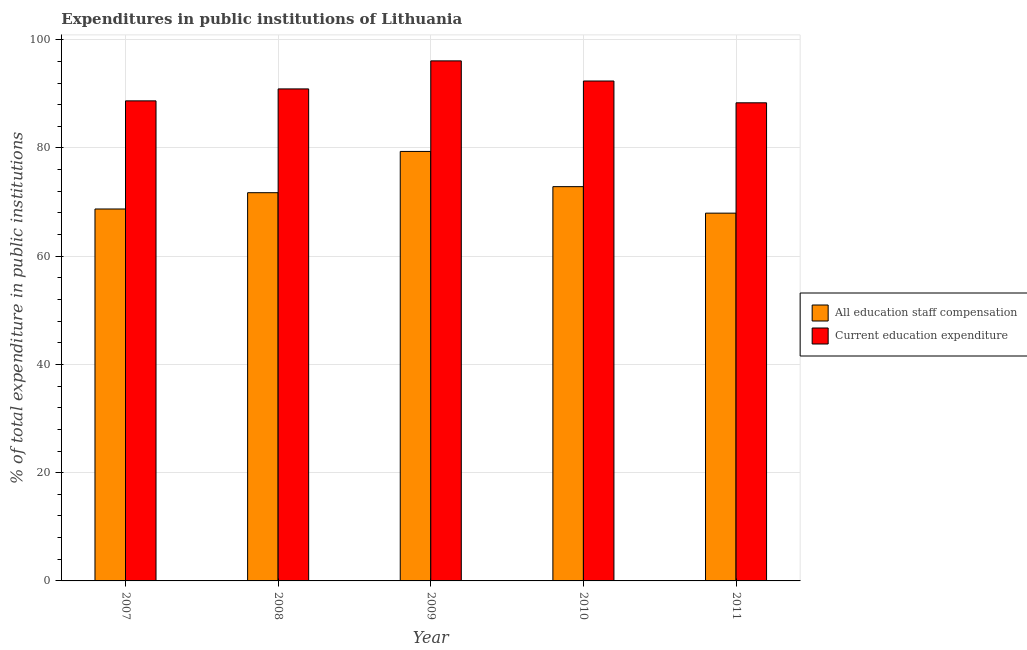How many groups of bars are there?
Make the answer very short. 5. Are the number of bars per tick equal to the number of legend labels?
Your answer should be compact. Yes. Are the number of bars on each tick of the X-axis equal?
Your answer should be compact. Yes. How many bars are there on the 3rd tick from the left?
Make the answer very short. 2. What is the expenditure in staff compensation in 2009?
Your answer should be very brief. 79.36. Across all years, what is the maximum expenditure in education?
Give a very brief answer. 96.09. Across all years, what is the minimum expenditure in education?
Your answer should be compact. 88.34. What is the total expenditure in staff compensation in the graph?
Offer a terse response. 360.62. What is the difference between the expenditure in education in 2008 and that in 2010?
Ensure brevity in your answer.  -1.46. What is the difference between the expenditure in staff compensation in 2008 and the expenditure in education in 2007?
Offer a terse response. 3.01. What is the average expenditure in education per year?
Keep it short and to the point. 91.28. In how many years, is the expenditure in education greater than 64 %?
Provide a succinct answer. 5. What is the ratio of the expenditure in staff compensation in 2007 to that in 2011?
Your answer should be compact. 1.01. Is the expenditure in staff compensation in 2010 less than that in 2011?
Your response must be concise. No. What is the difference between the highest and the second highest expenditure in education?
Your answer should be very brief. 3.72. What is the difference between the highest and the lowest expenditure in staff compensation?
Your answer should be very brief. 11.4. Is the sum of the expenditure in staff compensation in 2007 and 2009 greater than the maximum expenditure in education across all years?
Offer a terse response. Yes. What does the 2nd bar from the left in 2011 represents?
Your answer should be very brief. Current education expenditure. What does the 1st bar from the right in 2008 represents?
Provide a succinct answer. Current education expenditure. How many bars are there?
Keep it short and to the point. 10. Are all the bars in the graph horizontal?
Offer a very short reply. No. How many years are there in the graph?
Make the answer very short. 5. What is the difference between two consecutive major ticks on the Y-axis?
Provide a succinct answer. 20. Are the values on the major ticks of Y-axis written in scientific E-notation?
Your answer should be very brief. No. Does the graph contain any zero values?
Your answer should be compact. No. Does the graph contain grids?
Ensure brevity in your answer.  Yes. How many legend labels are there?
Keep it short and to the point. 2. How are the legend labels stacked?
Your answer should be very brief. Vertical. What is the title of the graph?
Ensure brevity in your answer.  Expenditures in public institutions of Lithuania. What is the label or title of the X-axis?
Provide a short and direct response. Year. What is the label or title of the Y-axis?
Your response must be concise. % of total expenditure in public institutions. What is the % of total expenditure in public institutions of All education staff compensation in 2007?
Offer a very short reply. 68.72. What is the % of total expenditure in public institutions in Current education expenditure in 2007?
Offer a very short reply. 88.7. What is the % of total expenditure in public institutions of All education staff compensation in 2008?
Offer a terse response. 71.73. What is the % of total expenditure in public institutions of Current education expenditure in 2008?
Give a very brief answer. 90.91. What is the % of total expenditure in public institutions of All education staff compensation in 2009?
Your response must be concise. 79.36. What is the % of total expenditure in public institutions of Current education expenditure in 2009?
Provide a short and direct response. 96.09. What is the % of total expenditure in public institutions of All education staff compensation in 2010?
Provide a succinct answer. 72.85. What is the % of total expenditure in public institutions of Current education expenditure in 2010?
Make the answer very short. 92.37. What is the % of total expenditure in public institutions of All education staff compensation in 2011?
Ensure brevity in your answer.  67.96. What is the % of total expenditure in public institutions of Current education expenditure in 2011?
Keep it short and to the point. 88.34. Across all years, what is the maximum % of total expenditure in public institutions in All education staff compensation?
Offer a terse response. 79.36. Across all years, what is the maximum % of total expenditure in public institutions of Current education expenditure?
Keep it short and to the point. 96.09. Across all years, what is the minimum % of total expenditure in public institutions in All education staff compensation?
Provide a succinct answer. 67.96. Across all years, what is the minimum % of total expenditure in public institutions of Current education expenditure?
Offer a terse response. 88.34. What is the total % of total expenditure in public institutions in All education staff compensation in the graph?
Provide a short and direct response. 360.62. What is the total % of total expenditure in public institutions in Current education expenditure in the graph?
Ensure brevity in your answer.  456.42. What is the difference between the % of total expenditure in public institutions in All education staff compensation in 2007 and that in 2008?
Ensure brevity in your answer.  -3.01. What is the difference between the % of total expenditure in public institutions in Current education expenditure in 2007 and that in 2008?
Your answer should be very brief. -2.21. What is the difference between the % of total expenditure in public institutions in All education staff compensation in 2007 and that in 2009?
Provide a short and direct response. -10.63. What is the difference between the % of total expenditure in public institutions in Current education expenditure in 2007 and that in 2009?
Keep it short and to the point. -7.39. What is the difference between the % of total expenditure in public institutions in All education staff compensation in 2007 and that in 2010?
Give a very brief answer. -4.13. What is the difference between the % of total expenditure in public institutions of Current education expenditure in 2007 and that in 2010?
Your answer should be very brief. -3.67. What is the difference between the % of total expenditure in public institutions in All education staff compensation in 2007 and that in 2011?
Provide a short and direct response. 0.77. What is the difference between the % of total expenditure in public institutions of Current education expenditure in 2007 and that in 2011?
Offer a very short reply. 0.36. What is the difference between the % of total expenditure in public institutions in All education staff compensation in 2008 and that in 2009?
Your answer should be compact. -7.62. What is the difference between the % of total expenditure in public institutions in Current education expenditure in 2008 and that in 2009?
Your answer should be very brief. -5.18. What is the difference between the % of total expenditure in public institutions in All education staff compensation in 2008 and that in 2010?
Ensure brevity in your answer.  -1.12. What is the difference between the % of total expenditure in public institutions in Current education expenditure in 2008 and that in 2010?
Your response must be concise. -1.46. What is the difference between the % of total expenditure in public institutions of All education staff compensation in 2008 and that in 2011?
Your answer should be very brief. 3.78. What is the difference between the % of total expenditure in public institutions in Current education expenditure in 2008 and that in 2011?
Ensure brevity in your answer.  2.57. What is the difference between the % of total expenditure in public institutions in All education staff compensation in 2009 and that in 2010?
Offer a very short reply. 6.51. What is the difference between the % of total expenditure in public institutions in Current education expenditure in 2009 and that in 2010?
Make the answer very short. 3.72. What is the difference between the % of total expenditure in public institutions of All education staff compensation in 2009 and that in 2011?
Give a very brief answer. 11.4. What is the difference between the % of total expenditure in public institutions of Current education expenditure in 2009 and that in 2011?
Provide a short and direct response. 7.75. What is the difference between the % of total expenditure in public institutions of All education staff compensation in 2010 and that in 2011?
Your response must be concise. 4.89. What is the difference between the % of total expenditure in public institutions in Current education expenditure in 2010 and that in 2011?
Keep it short and to the point. 4.03. What is the difference between the % of total expenditure in public institutions in All education staff compensation in 2007 and the % of total expenditure in public institutions in Current education expenditure in 2008?
Offer a very short reply. -22.19. What is the difference between the % of total expenditure in public institutions of All education staff compensation in 2007 and the % of total expenditure in public institutions of Current education expenditure in 2009?
Provide a short and direct response. -27.37. What is the difference between the % of total expenditure in public institutions of All education staff compensation in 2007 and the % of total expenditure in public institutions of Current education expenditure in 2010?
Provide a short and direct response. -23.65. What is the difference between the % of total expenditure in public institutions in All education staff compensation in 2007 and the % of total expenditure in public institutions in Current education expenditure in 2011?
Ensure brevity in your answer.  -19.62. What is the difference between the % of total expenditure in public institutions of All education staff compensation in 2008 and the % of total expenditure in public institutions of Current education expenditure in 2009?
Ensure brevity in your answer.  -24.36. What is the difference between the % of total expenditure in public institutions of All education staff compensation in 2008 and the % of total expenditure in public institutions of Current education expenditure in 2010?
Give a very brief answer. -20.64. What is the difference between the % of total expenditure in public institutions in All education staff compensation in 2008 and the % of total expenditure in public institutions in Current education expenditure in 2011?
Give a very brief answer. -16.61. What is the difference between the % of total expenditure in public institutions of All education staff compensation in 2009 and the % of total expenditure in public institutions of Current education expenditure in 2010?
Offer a terse response. -13.01. What is the difference between the % of total expenditure in public institutions in All education staff compensation in 2009 and the % of total expenditure in public institutions in Current education expenditure in 2011?
Keep it short and to the point. -8.99. What is the difference between the % of total expenditure in public institutions in All education staff compensation in 2010 and the % of total expenditure in public institutions in Current education expenditure in 2011?
Ensure brevity in your answer.  -15.49. What is the average % of total expenditure in public institutions of All education staff compensation per year?
Ensure brevity in your answer.  72.12. What is the average % of total expenditure in public institutions of Current education expenditure per year?
Your answer should be compact. 91.28. In the year 2007, what is the difference between the % of total expenditure in public institutions of All education staff compensation and % of total expenditure in public institutions of Current education expenditure?
Provide a succinct answer. -19.98. In the year 2008, what is the difference between the % of total expenditure in public institutions in All education staff compensation and % of total expenditure in public institutions in Current education expenditure?
Your answer should be compact. -19.18. In the year 2009, what is the difference between the % of total expenditure in public institutions of All education staff compensation and % of total expenditure in public institutions of Current education expenditure?
Ensure brevity in your answer.  -16.73. In the year 2010, what is the difference between the % of total expenditure in public institutions in All education staff compensation and % of total expenditure in public institutions in Current education expenditure?
Your answer should be very brief. -19.52. In the year 2011, what is the difference between the % of total expenditure in public institutions of All education staff compensation and % of total expenditure in public institutions of Current education expenditure?
Your response must be concise. -20.39. What is the ratio of the % of total expenditure in public institutions of All education staff compensation in 2007 to that in 2008?
Provide a short and direct response. 0.96. What is the ratio of the % of total expenditure in public institutions in Current education expenditure in 2007 to that in 2008?
Offer a terse response. 0.98. What is the ratio of the % of total expenditure in public institutions of All education staff compensation in 2007 to that in 2009?
Offer a very short reply. 0.87. What is the ratio of the % of total expenditure in public institutions of Current education expenditure in 2007 to that in 2009?
Give a very brief answer. 0.92. What is the ratio of the % of total expenditure in public institutions of All education staff compensation in 2007 to that in 2010?
Your answer should be very brief. 0.94. What is the ratio of the % of total expenditure in public institutions in Current education expenditure in 2007 to that in 2010?
Your response must be concise. 0.96. What is the ratio of the % of total expenditure in public institutions in All education staff compensation in 2007 to that in 2011?
Keep it short and to the point. 1.01. What is the ratio of the % of total expenditure in public institutions in All education staff compensation in 2008 to that in 2009?
Your answer should be compact. 0.9. What is the ratio of the % of total expenditure in public institutions of Current education expenditure in 2008 to that in 2009?
Offer a very short reply. 0.95. What is the ratio of the % of total expenditure in public institutions of All education staff compensation in 2008 to that in 2010?
Ensure brevity in your answer.  0.98. What is the ratio of the % of total expenditure in public institutions in Current education expenditure in 2008 to that in 2010?
Offer a very short reply. 0.98. What is the ratio of the % of total expenditure in public institutions in All education staff compensation in 2008 to that in 2011?
Ensure brevity in your answer.  1.06. What is the ratio of the % of total expenditure in public institutions of Current education expenditure in 2008 to that in 2011?
Give a very brief answer. 1.03. What is the ratio of the % of total expenditure in public institutions of All education staff compensation in 2009 to that in 2010?
Offer a terse response. 1.09. What is the ratio of the % of total expenditure in public institutions in Current education expenditure in 2009 to that in 2010?
Give a very brief answer. 1.04. What is the ratio of the % of total expenditure in public institutions of All education staff compensation in 2009 to that in 2011?
Ensure brevity in your answer.  1.17. What is the ratio of the % of total expenditure in public institutions of Current education expenditure in 2009 to that in 2011?
Offer a terse response. 1.09. What is the ratio of the % of total expenditure in public institutions of All education staff compensation in 2010 to that in 2011?
Ensure brevity in your answer.  1.07. What is the ratio of the % of total expenditure in public institutions in Current education expenditure in 2010 to that in 2011?
Your answer should be compact. 1.05. What is the difference between the highest and the second highest % of total expenditure in public institutions of All education staff compensation?
Offer a very short reply. 6.51. What is the difference between the highest and the second highest % of total expenditure in public institutions of Current education expenditure?
Ensure brevity in your answer.  3.72. What is the difference between the highest and the lowest % of total expenditure in public institutions of All education staff compensation?
Provide a succinct answer. 11.4. What is the difference between the highest and the lowest % of total expenditure in public institutions in Current education expenditure?
Your answer should be very brief. 7.75. 